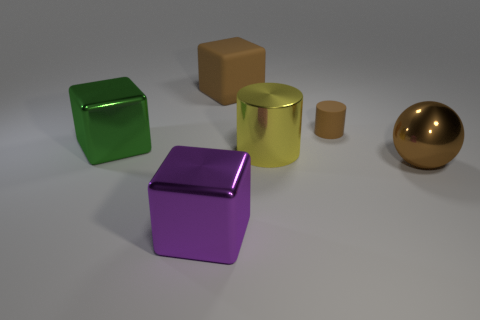Subtract all brown matte blocks. How many blocks are left? 2 Subtract 0 blue blocks. How many objects are left? 6 Subtract all spheres. How many objects are left? 5 Subtract 2 cubes. How many cubes are left? 1 Subtract all purple balls. Subtract all purple cubes. How many balls are left? 1 Subtract all cyan cylinders. How many yellow balls are left? 0 Subtract all metallic spheres. Subtract all small cyan metal things. How many objects are left? 5 Add 1 large matte cubes. How many large matte cubes are left? 2 Add 1 tiny gray rubber cubes. How many tiny gray rubber cubes exist? 1 Add 3 big cylinders. How many objects exist? 9 